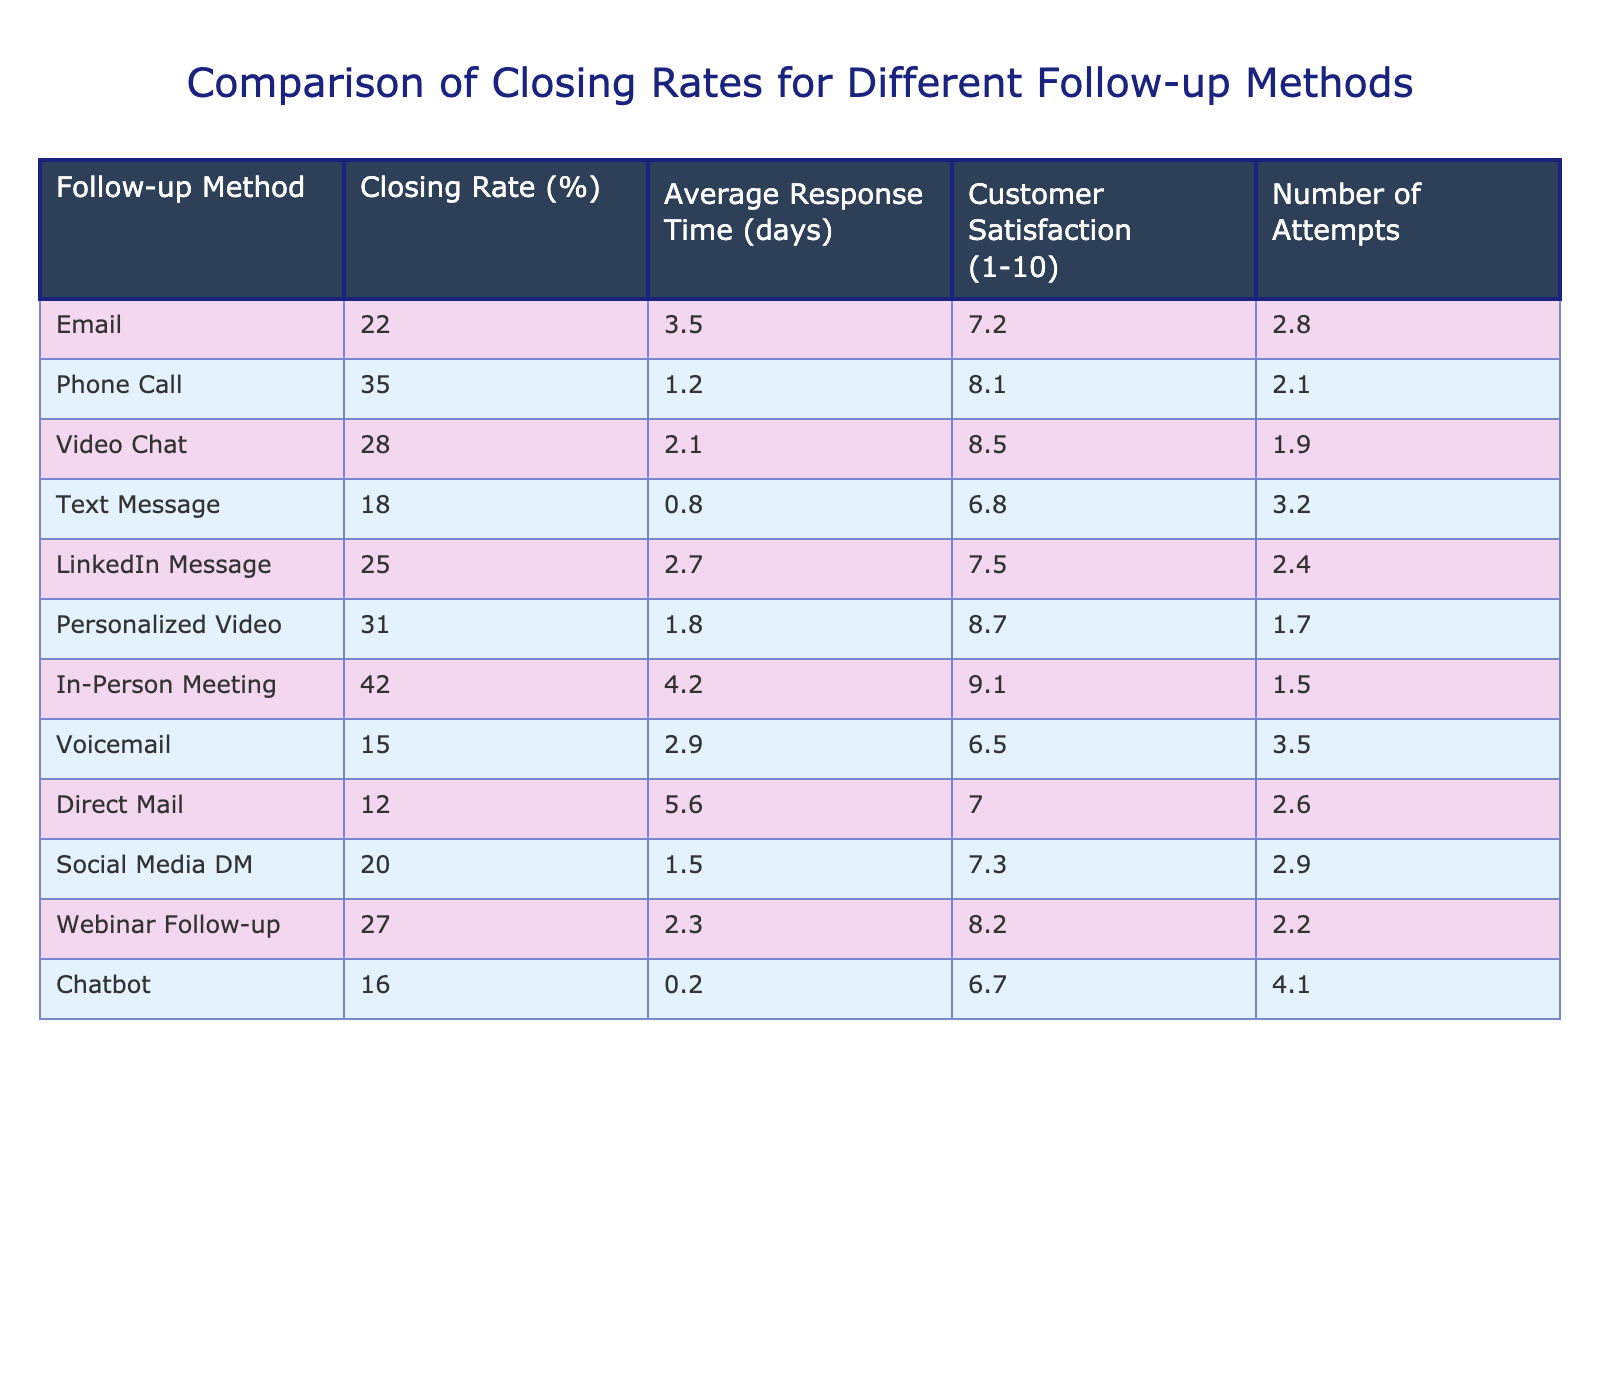What is the closing rate for the Phone Call follow-up method? The table lists the closing rate for each follow-up method, and for the Phone Call method, it shows a closing rate of 35%.
Answer: 35% Which follow-up method has the highest customer satisfaction rating? Looking at the Customer Satisfaction column, the In-Person Meeting has the highest rating of 9.1 out of 10.
Answer: In-Person Meeting What is the average closing rate of all follow-up methods? To find the average, sum all the closing rates (22 + 35 + 28 + 18 + 25 + 31 + 42 + 15 + 12 + 20 + 27 + 16) =  359, and divide by the number of methods (12): 359/12 = 29.92.
Answer: 29.92% Is the closing rate for Text Message follow-up higher than that for Direct Mail? The closing rate for Text Message is 18%, while for Direct Mail, it is 12%. Since 18% is greater than 12%, the answer is yes.
Answer: Yes What is the difference in closing rates between the In-Person Meeting and the Voicemail follow-up methods? The In-Person Meeting has a closing rate of 42%, while Voicemail has a closing rate of 15%. Calculating the difference: 42% - 15% = 27%.
Answer: 27% Which follow-up method has the lowest average response time? The average response times show that the Chatbot method has the lowest at 0.2 days.
Answer: Chatbot If you categorized the follow-up methods into two groups based on their closing rates (above and below 25%), how many methods would fall under each category? Counting the methods above 25% (Phone Call, Video Chat, Personalized Video, In-Person Meeting), there are 4 methods. Those below 25% are Email, Text Message, LinkedIn Message, Voicemail, Direct Mail, Social Media DM, Chatbot (which total to 8).
Answer: 4 above 25%; 8 below 25% Find the follow-up method with the most attempts and state its closing rate. The Text Message method has the highest number of attempts at 3.2, with a corresponding closing rate of 18%.
Answer: Text Message, 18% What is the average customer satisfaction rating for methods with a closing rate above 30%? The methods with closing rates above 30% are Phone Call (8.1), Personalized Video (8.7), In-Person Meeting (9.1), and Video Chat (8.5). The average is calculated as follows: (8.1 + 8.7 + 9.1 + 8.5) = 34.4, divided by the number of methods (4): 34.4 / 4 = 8.6.
Answer: 8.6 Is it true that Email has a higher closing rate than Social Media DM? The closing rate for Email is 22% while Social Media DM is 20%. Since 22% is greater than 20%, the statement is true.
Answer: True 